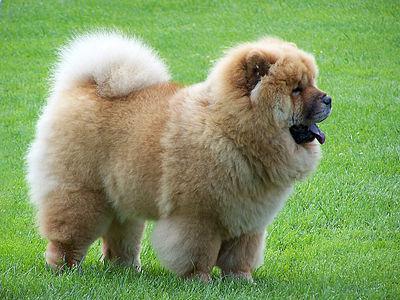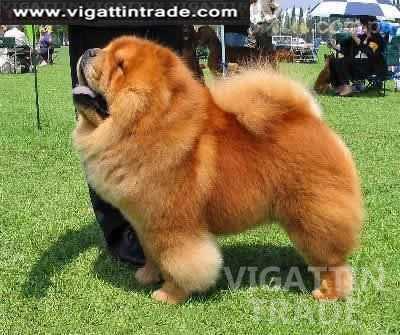The first image is the image on the left, the second image is the image on the right. Evaluate the accuracy of this statement regarding the images: "The dogs are standing outside, but not on the grass.". Is it true? Answer yes or no. No. The first image is the image on the left, the second image is the image on the right. For the images displayed, is the sentence "A chow with orange-tinged fur is posed on a greenish surface in at least one image." factually correct? Answer yes or no. Yes. 